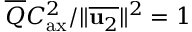Convert formula to latex. <formula><loc_0><loc_0><loc_500><loc_500>\overline { Q } C _ { a x } ^ { 2 } / \| \overline { { u _ { 2 } } } \| ^ { 2 } = 1</formula> 